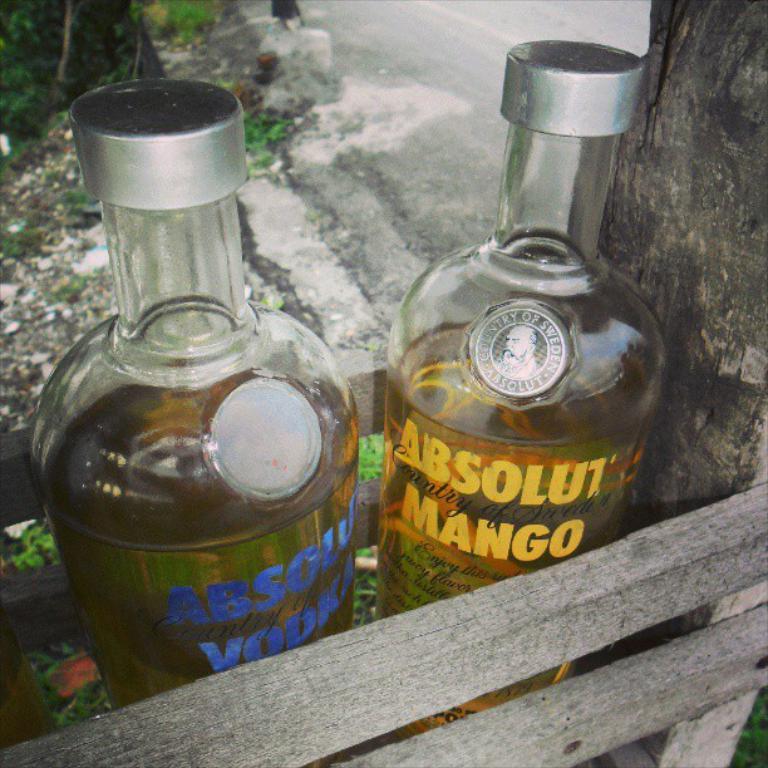What fruit flavor is that?
Provide a short and direct response. Mango. 